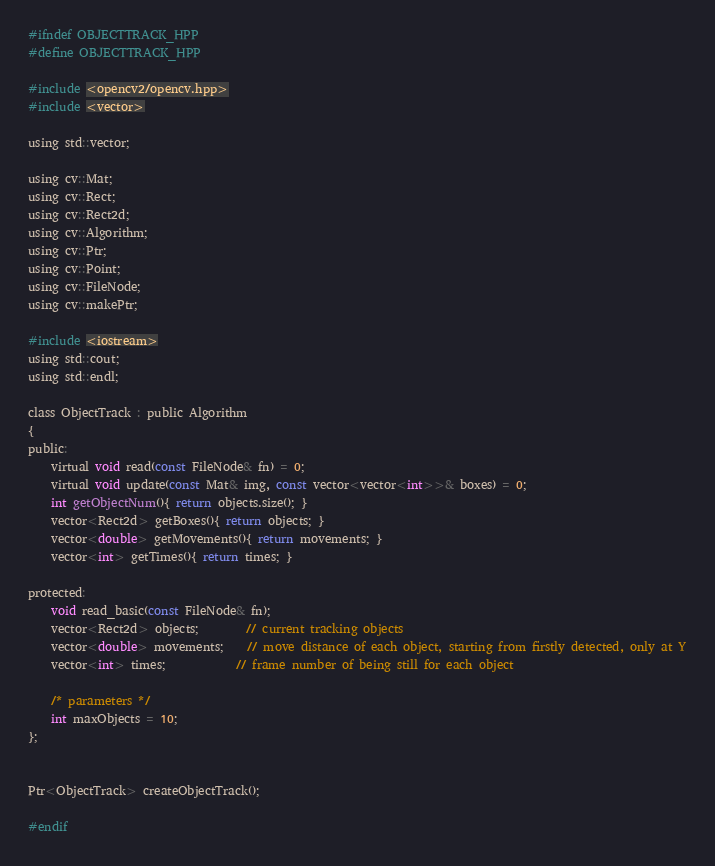Convert code to text. <code><loc_0><loc_0><loc_500><loc_500><_C_>#ifndef OBJECTTRACK_HPP
#define OBJECTTRACK_HPP

#include <opencv2/opencv.hpp>
#include <vector>

using std::vector;

using cv::Mat;
using cv::Rect;
using cv::Rect2d;
using cv::Algorithm;
using cv::Ptr;
using cv::Point;
using cv::FileNode;
using cv::makePtr;

#include <iostream>
using std::cout;
using std::endl;

class ObjectTrack : public Algorithm
{
public:
    virtual void read(const FileNode& fn) = 0;
    virtual void update(const Mat& img, const vector<vector<int>>& boxes) = 0;
    int getObjectNum(){ return objects.size(); }
    vector<Rect2d> getBoxes(){ return objects; }
    vector<double> getMovements(){ return movements; }
    vector<int> getTimes(){ return times; }

protected:
    void read_basic(const FileNode& fn);
    vector<Rect2d> objects;		// current tracking objects
    vector<double> movements;	// move distance of each object, starting from firstly detected, only at Y
    vector<int> times;			// frame number of being still for each object

    /* parameters */
    int maxObjects = 10;
};


Ptr<ObjectTrack> createObjectTrack();

#endif
</code> 